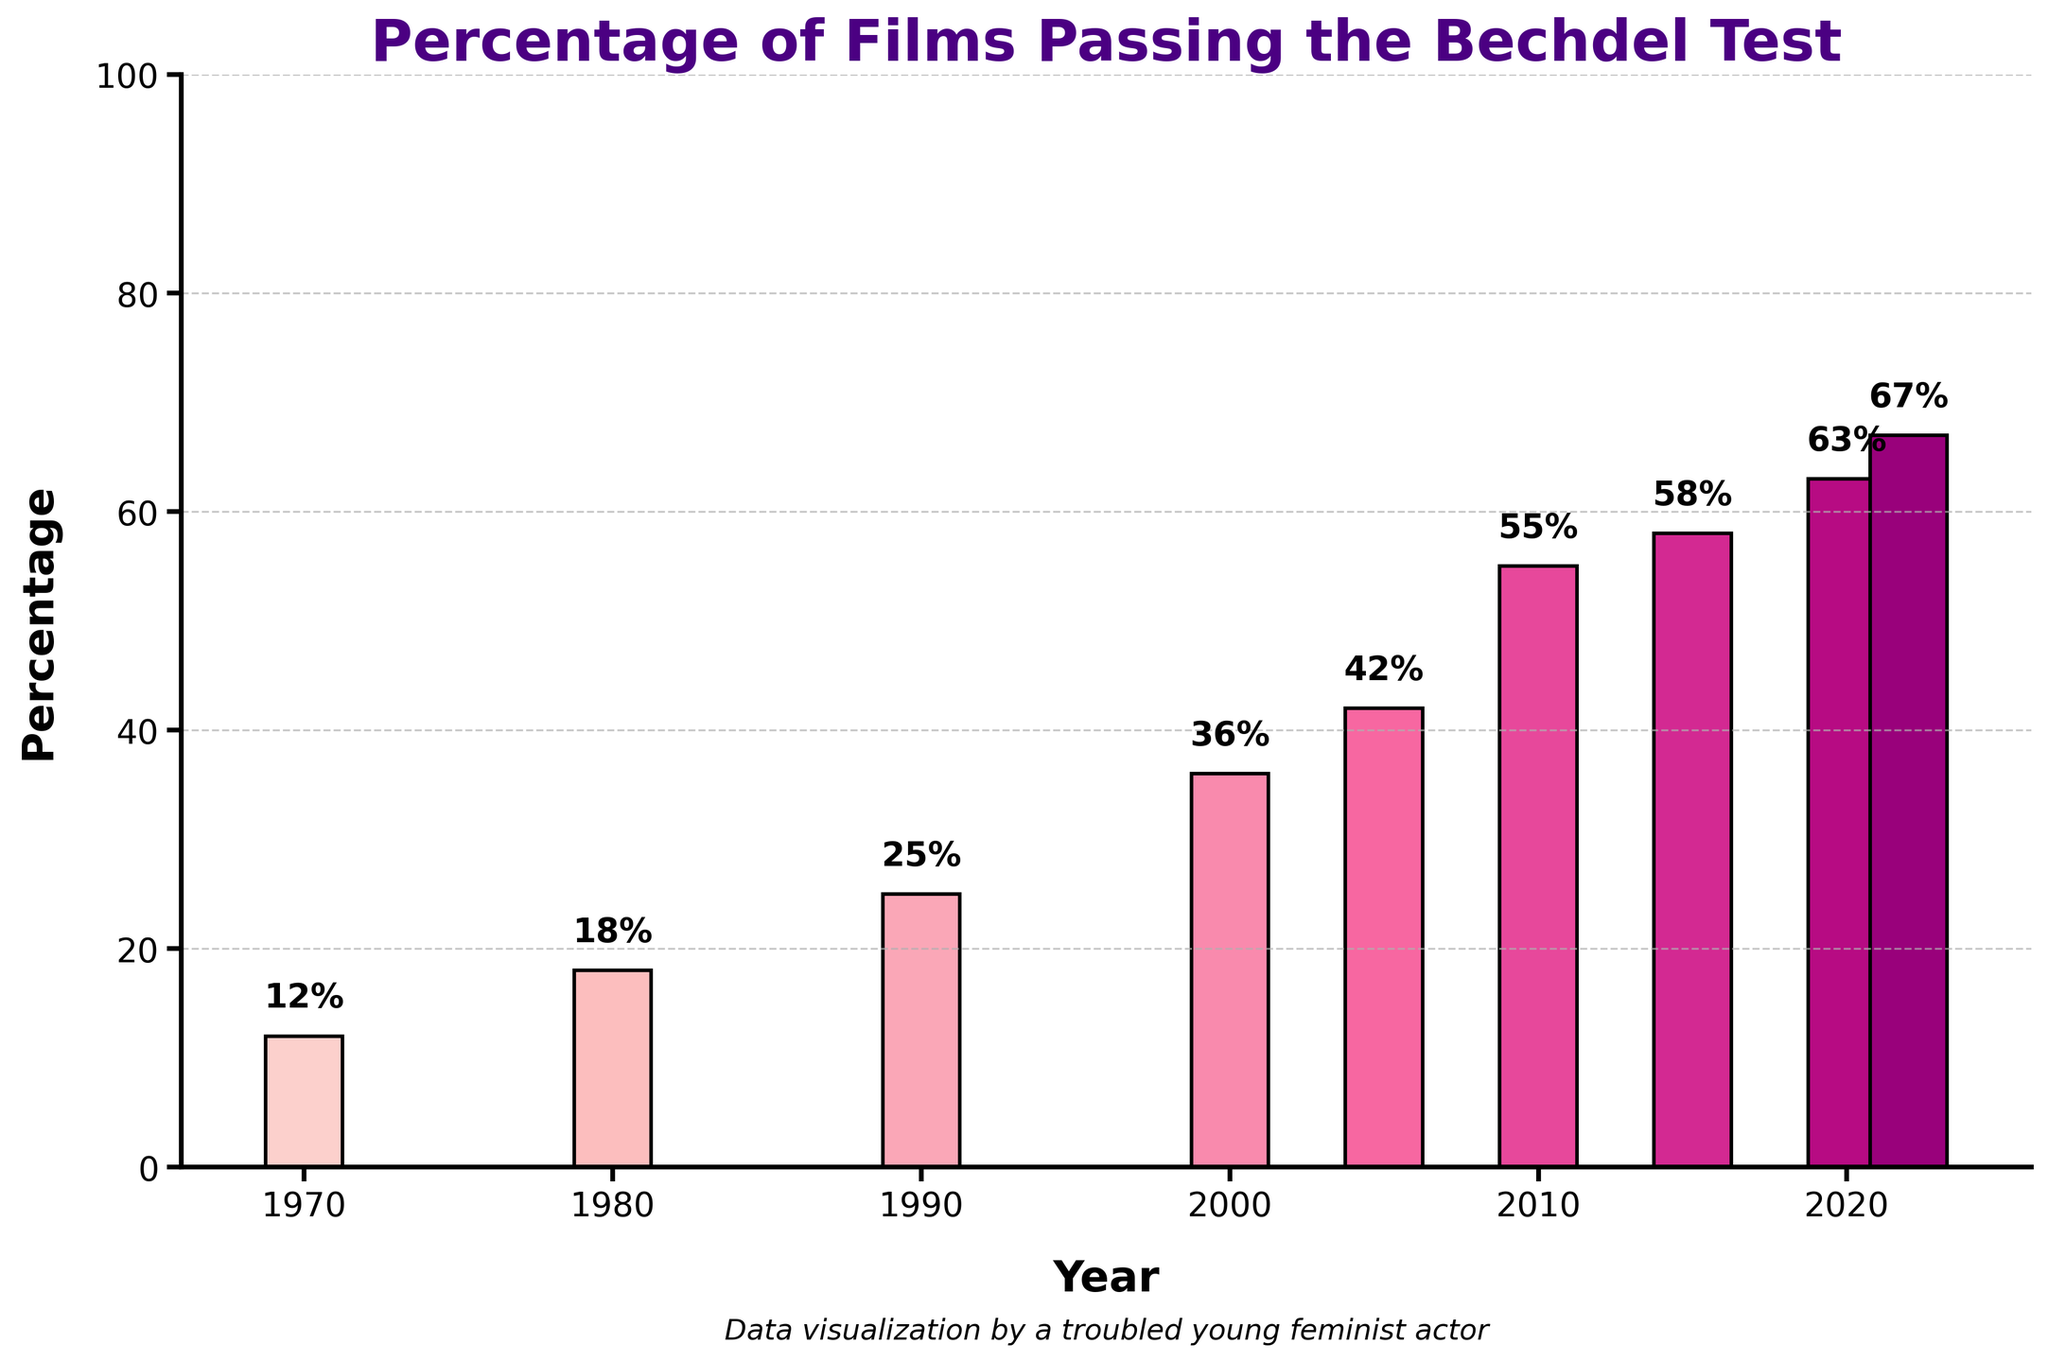Which year saw the highest percentage of films passing the Bechdel test? The highest bar corresponds to the year 2022 with a percentage of 67%.
Answer: 2022 What was the percentage increase in films passing the Bechdel test from 1970 to 2022? The percentage in 1970 was 12%, and in 2022 it was 67%. The increase is 67% - 12% = 55%.
Answer: 55% Which decade saw the greatest improvement in the percentage of films passing the Bechdel test? Comparing the differences, 1970-1980 increased by 6%, 1980-1990 by 7%, 1990-2000 by 11%, 2000-2005 by 6%, 2005-2010 by 13%, 2010-2015 by 3%, 2015-2020 by 5%, and 2020-2022 by 4%. The decade 2000-2010 saw an increase of 19% (36% to 55%), the greatest improvement.
Answer: 2000-2010 By how much did the percentage of films passing the Bechdel test change between 2010 and 2015? The percentage in 2010 was 55%, and in 2015 it was 58%. The difference is 58% - 55% = 3%.
Answer: 3% Compare the percentage of films passing the Bechdel test in 1990 and 2005. Which year had a higher percentage, and by how much? In 1990, the percentage was 25%. In 2005, it was 42%. 2005 had a higher percentage by 42% - 25% = 17%.
Answer: 2005 by 17% Which years had an increase of 5% or greater from the previous data point? The years with increases of 5% or greater are from 1980 to 1990 (7%), from 1990 to 2000 (11%), from 2000 to 2010 (19%), and from 2015 to 2020 (5%).
Answer: 1990, 2000, 2010, 2020 What is the overall trend in the percentage of films passing the Bechdel test from 1970 to 2022? The overall trend is an increasing percentage of films passing the Bechdel test from 12% in 1970 to 67% in 2022.
Answer: Increasing trend Between which consecutive data points is the smallest increase in the percentage of films passing the Bechdel test observed? The smallest increase is between 2010 to 2015, where the increase was just 3%.
Answer: 2010-2015 